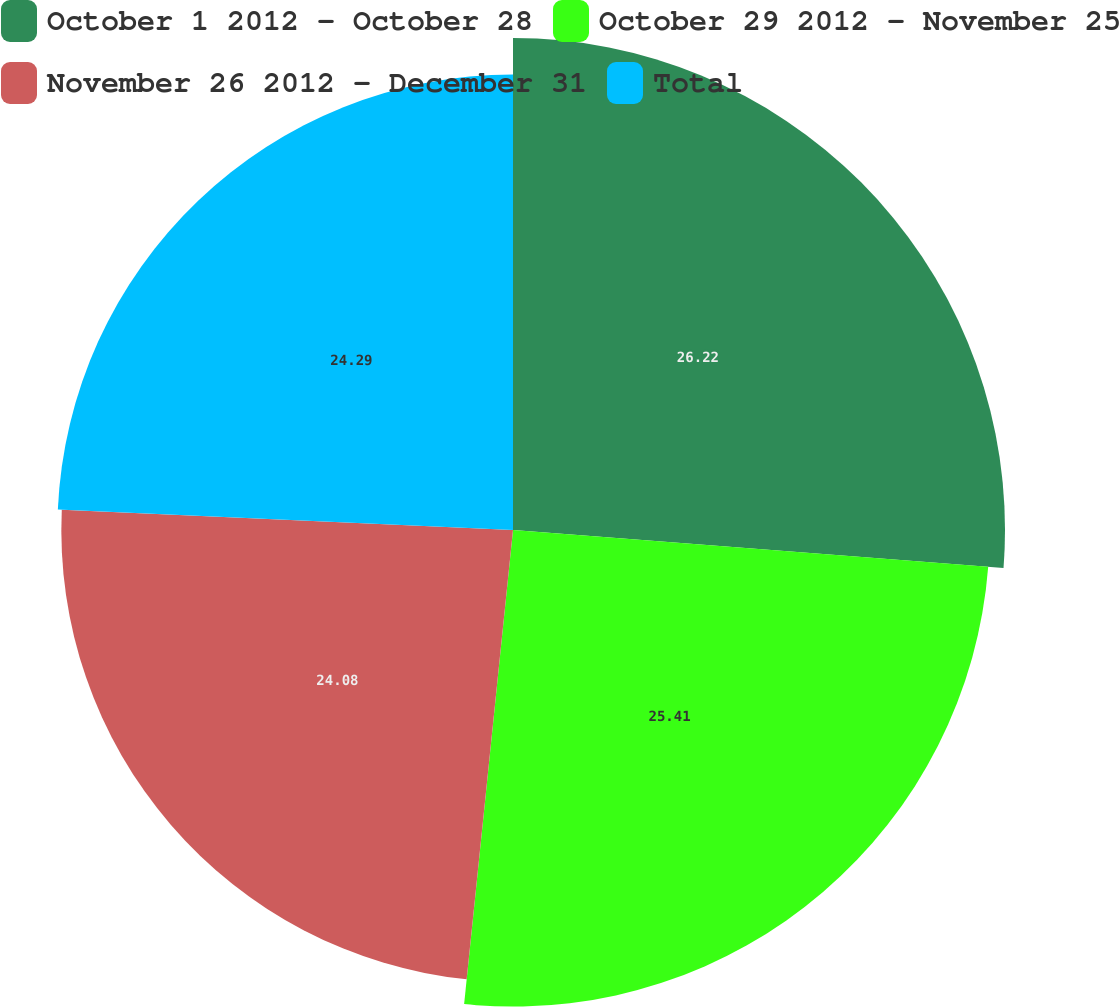<chart> <loc_0><loc_0><loc_500><loc_500><pie_chart><fcel>October 1 2012 - October 28<fcel>October 29 2012 - November 25<fcel>November 26 2012 - December 31<fcel>Total<nl><fcel>26.23%<fcel>25.41%<fcel>24.08%<fcel>24.29%<nl></chart> 